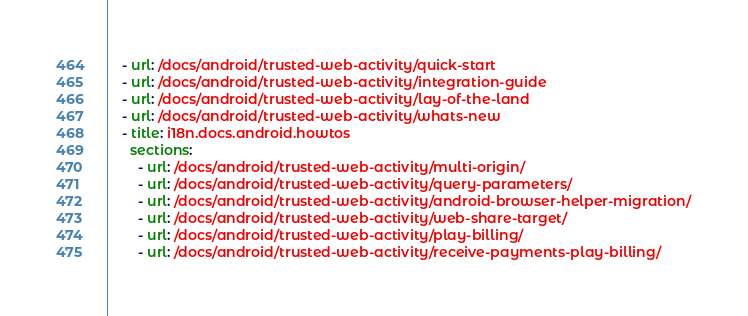<code> <loc_0><loc_0><loc_500><loc_500><_YAML_>    - url: /docs/android/trusted-web-activity/quick-start
    - url: /docs/android/trusted-web-activity/integration-guide
    - url: /docs/android/trusted-web-activity/lay-of-the-land
    - url: /docs/android/trusted-web-activity/whats-new
    - title: i18n.docs.android.howtos
      sections:
        - url: /docs/android/trusted-web-activity/multi-origin/
        - url: /docs/android/trusted-web-activity/query-parameters/
        - url: /docs/android/trusted-web-activity/android-browser-helper-migration/
        - url: /docs/android/trusted-web-activity/web-share-target/
        - url: /docs/android/trusted-web-activity/play-billing/
        - url: /docs/android/trusted-web-activity/receive-payments-play-billing/
</code> 